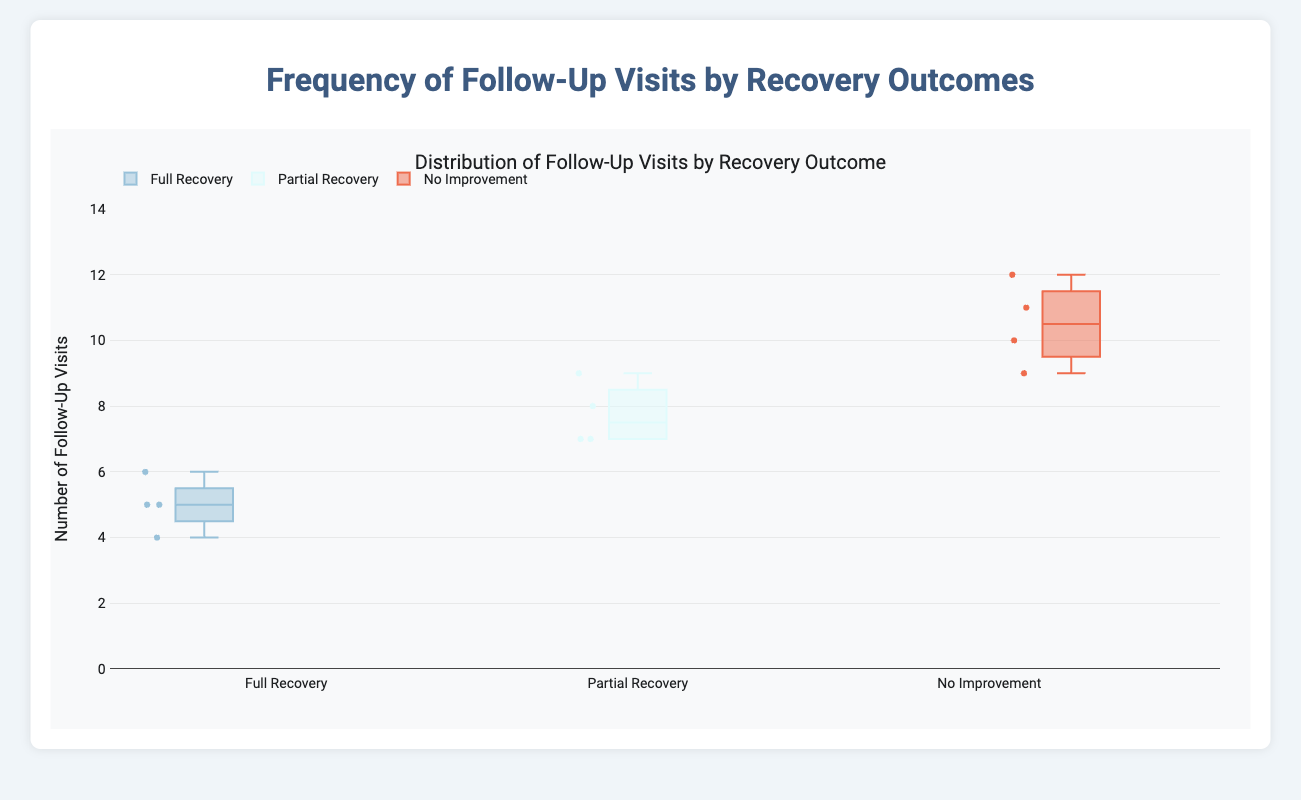What is the title of the plot? The title of the plot is usually indicated at the top in a larger or bold font. Here it is displayed directly above the plot area.
Answer: Distribution of Follow-Up Visits by Recovery Outcome How many follow-up visits were recorded for the "Partial Recovery" outcome? Look at the "Partial Recovery" box plot and count the number of data points (points outside the box).
Answer: 4 What is the median number of follow-up visits for "No Improvement"? The median is the line inside the box of the "No Improvement" category. In this plot, it is positioned between 10 and 11 follow-up visits.
Answer: 10 Which recovery outcome has the highest range of follow-up visits? The range is the difference between the maximum and minimum values of the data in each box plot. The "No Improvement" outcome spans the largest interval.
Answer: No Improvement What is the interquartile range (IQR) of follow-up visits for "Full Recovery"? The IQR is the range between the 25th percentile (bottom of the box) and the 75th percentile (top of the box). For "Full Recovery," this difference spans from 4 to 6 visits.
Answer: 2 Compare the medians of follow-up visits for "Full Recovery" and "Partial Recovery". To compare, look at the median lines in both categories. "Full Recovery" has a median around 5, while "Partial Recovery" has a median around 7.
Answer: "Partial Recovery" has a higher median Which recovery outcome has the smallest interquartile range (IQR)? Calculate IQR (top of the box minus the bottom of the box) for each category. "Partial Recovery" has the smallest range from 7 to 8.
Answer: Partial Recovery How many follow-up visits did the patients of Jane Smith with "No Improvement" have on average? Jane Smith's patients with "No Improvement" had follow-up visits at 10 and 10. Average these numbers.
Answer: 10 Does any category have outliers? Outliers are marked as individual points outside the whiskers of the box plot. No category in this plot shows these outliers outside the whiskers.
Answer: No What is the overall trend of follow-up visits with regard to recovery outcome? The trend can be deduced by observing the distributions in each category. The number of follow-up visits tends to increase as the recovery outcome worsens.
Answer: The more severe the recovery outcome, the more follow-up visits 